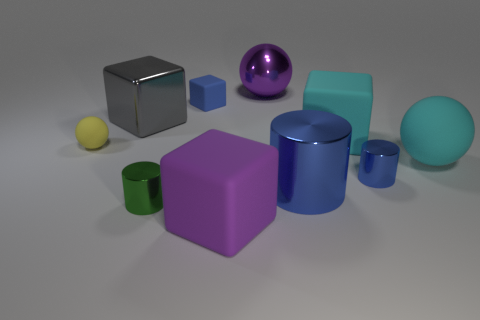Subtract 1 cubes. How many cubes are left? 3 Subtract all cylinders. How many objects are left? 7 Add 1 small things. How many small things exist? 5 Subtract 0 yellow cubes. How many objects are left? 10 Subtract all small cyan objects. Subtract all tiny green things. How many objects are left? 9 Add 5 large gray objects. How many large gray objects are left? 6 